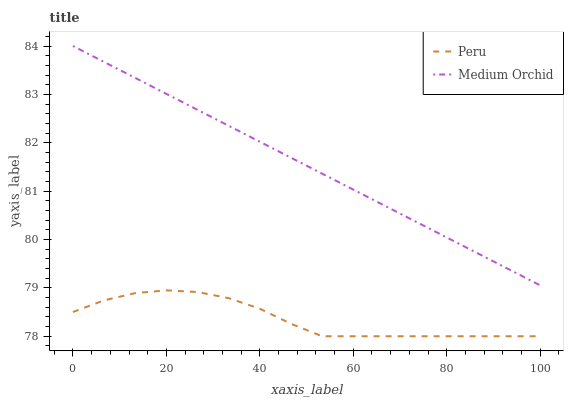Does Peru have the minimum area under the curve?
Answer yes or no. Yes. Does Medium Orchid have the maximum area under the curve?
Answer yes or no. Yes. Does Peru have the maximum area under the curve?
Answer yes or no. No. Is Medium Orchid the smoothest?
Answer yes or no. Yes. Is Peru the roughest?
Answer yes or no. Yes. Is Peru the smoothest?
Answer yes or no. No. Does Peru have the lowest value?
Answer yes or no. Yes. Does Medium Orchid have the highest value?
Answer yes or no. Yes. Does Peru have the highest value?
Answer yes or no. No. Is Peru less than Medium Orchid?
Answer yes or no. Yes. Is Medium Orchid greater than Peru?
Answer yes or no. Yes. Does Peru intersect Medium Orchid?
Answer yes or no. No. 